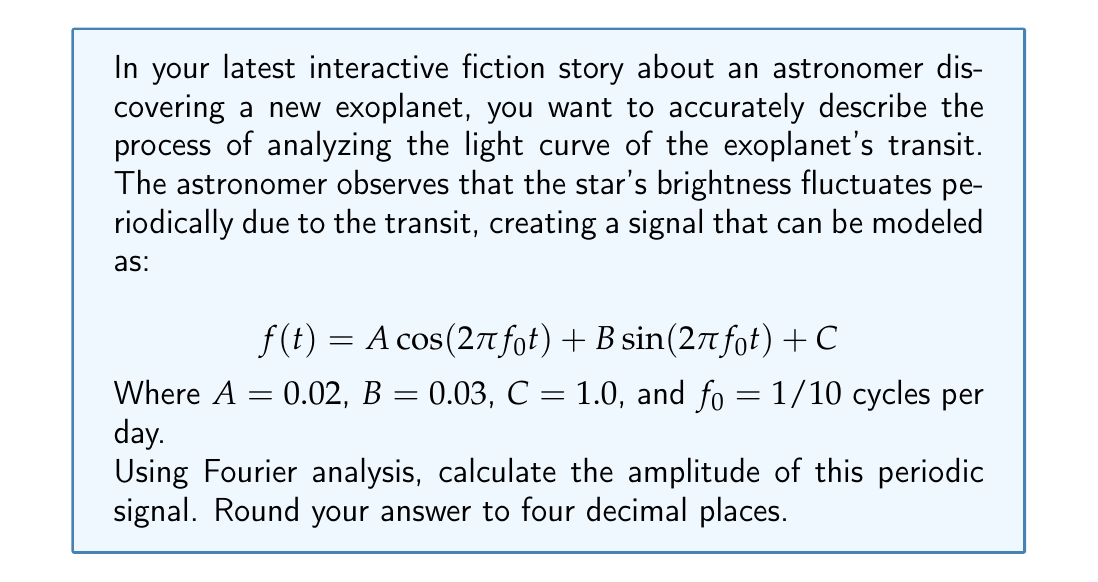Provide a solution to this math problem. To solve this problem, we need to understand that the amplitude of a periodic signal in Fourier analysis is determined by the magnitude of its Fourier coefficients. In this case, we have a signal represented by a cosine and sine term with the same frequency.

The general form of a periodic signal can be written as:

$$ f(t) = A \cos(2\pi f_0 t) + B \sin(2\pi f_0 t) + C $$

Where $A$ and $B$ are the Fourier coefficients, $f_0$ is the fundamental frequency, and $C$ is the DC offset.

To find the amplitude of this signal, we need to calculate:

$$ \text{Amplitude} = \sqrt{A^2 + B^2} $$

This formula comes from the fact that cosine and sine functions with the same frequency are orthogonal, and their combination creates a single sinusoid with an amplitude that depends on both coefficients.

Given:
$A = 0.02$
$B = 0.03$

Let's calculate:

$$ \text{Amplitude} = \sqrt{(0.02)^2 + (0.03)^2} $$
$$ = \sqrt{0.0004 + 0.0009} $$
$$ = \sqrt{0.0013} $$
$$ \approx 0.0360555127546399 $$

Rounding to four decimal places, we get 0.0361.

Note that the DC offset $C$ does not affect the amplitude of the periodic component of the signal, which is why it's not included in this calculation.
Answer: 0.0361 